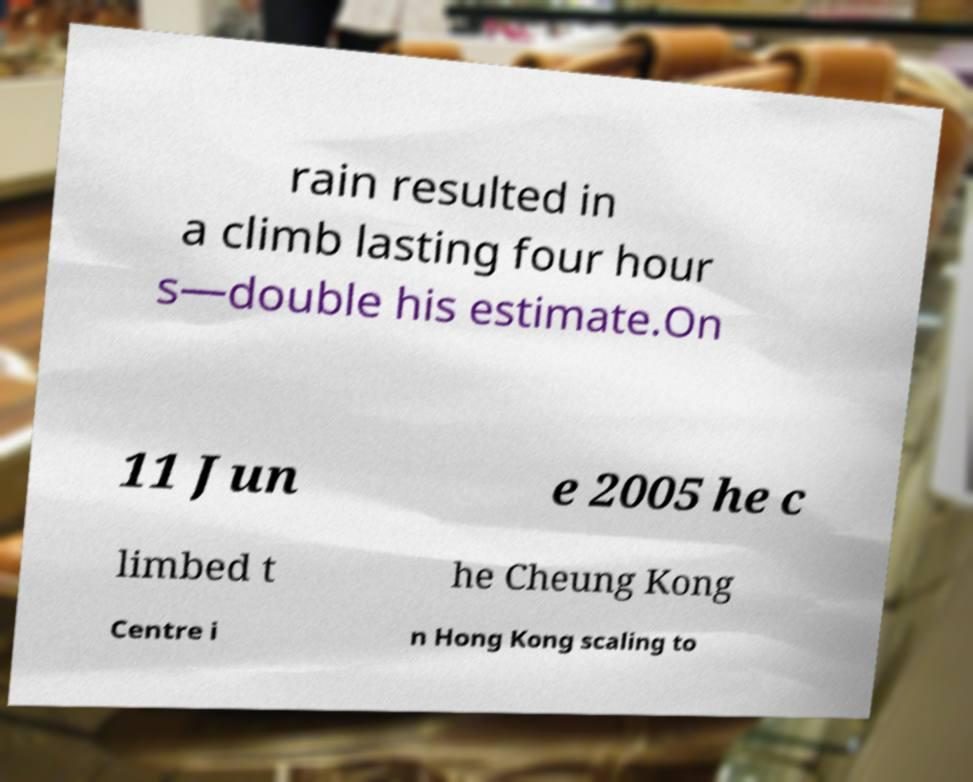Could you extract and type out the text from this image? rain resulted in a climb lasting four hour s—double his estimate.On 11 Jun e 2005 he c limbed t he Cheung Kong Centre i n Hong Kong scaling to 